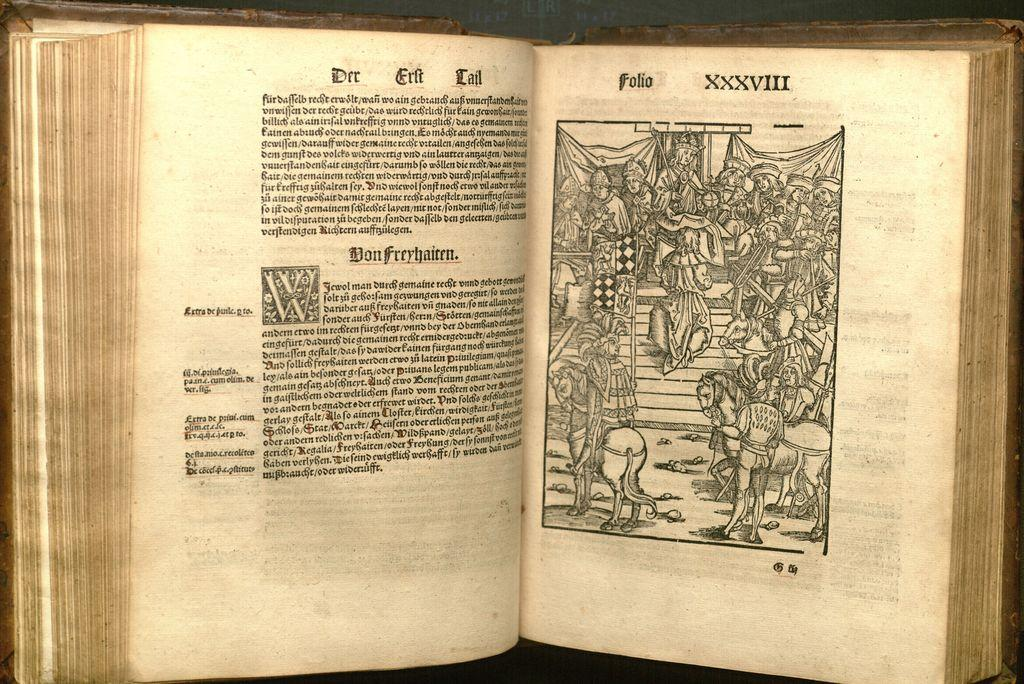What is the main object in the image? There is a book in the image. What type of content does the book contain? The book contains text. Are there any illustrations or images in the book? Yes, there are pictures of a group of people and pictures of horses in the book. What type of zinc can be seen in the image? There is no zinc present in the image. How many sheep are in the flock depicted in the image? There is no flock or sheep depicted in the image; it features a book with text and pictures of people and horses. 